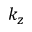<formula> <loc_0><loc_0><loc_500><loc_500>k _ { z }</formula> 